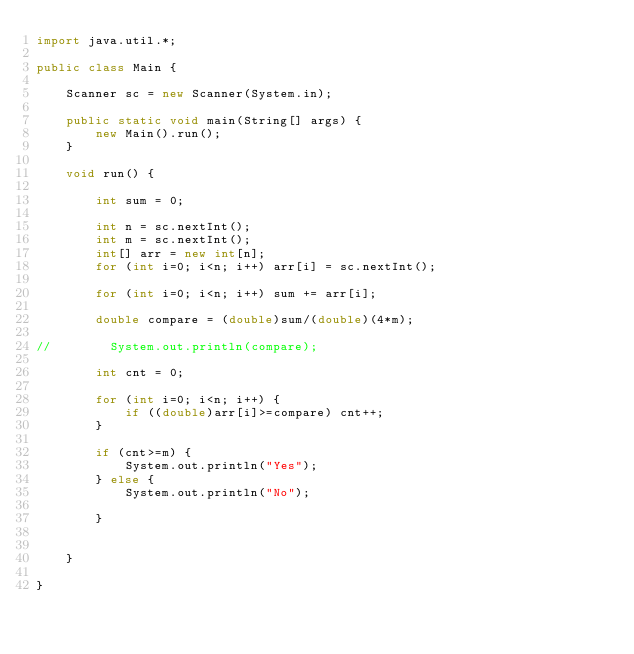Convert code to text. <code><loc_0><loc_0><loc_500><loc_500><_Java_>import java.util.*;

public class Main {

    Scanner sc = new Scanner(System.in);

    public static void main(String[] args) {
        new Main().run();
    }

    void run() {

        int sum = 0;

        int n = sc.nextInt();
        int m = sc.nextInt();
        int[] arr = new int[n];
        for (int i=0; i<n; i++) arr[i] = sc.nextInt();

        for (int i=0; i<n; i++) sum += arr[i];

        double compare = (double)sum/(double)(4*m);

//        System.out.println(compare);

        int cnt = 0;

        for (int i=0; i<n; i++) {
            if ((double)arr[i]>=compare) cnt++;
        }

        if (cnt>=m) {
            System.out.println("Yes");
        } else {
            System.out.println("No");

        }


    }

}
</code> 